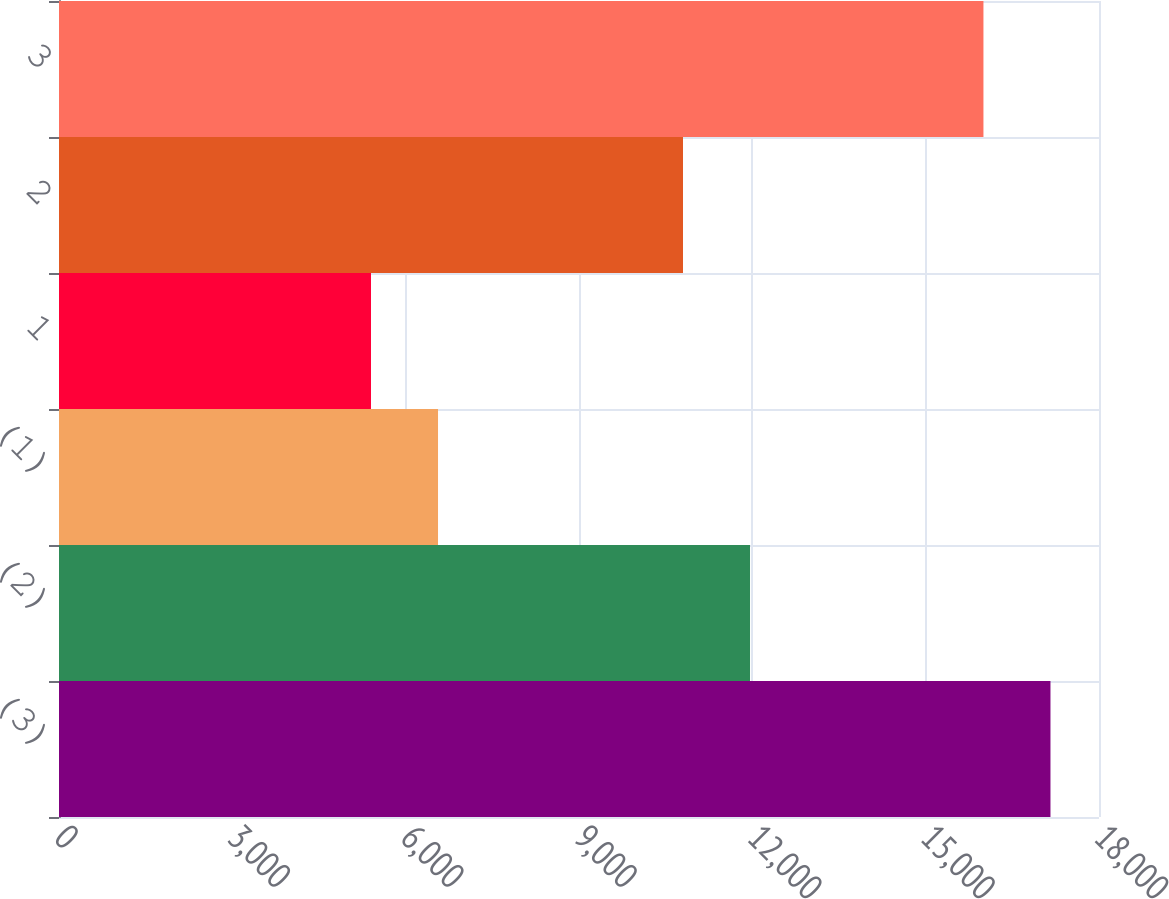Convert chart to OTSL. <chart><loc_0><loc_0><loc_500><loc_500><bar_chart><fcel>(3)<fcel>(2)<fcel>(1)<fcel>1<fcel>2<fcel>3<nl><fcel>17160<fcel>11960<fcel>6560<fcel>5400<fcel>10800<fcel>16000<nl></chart> 